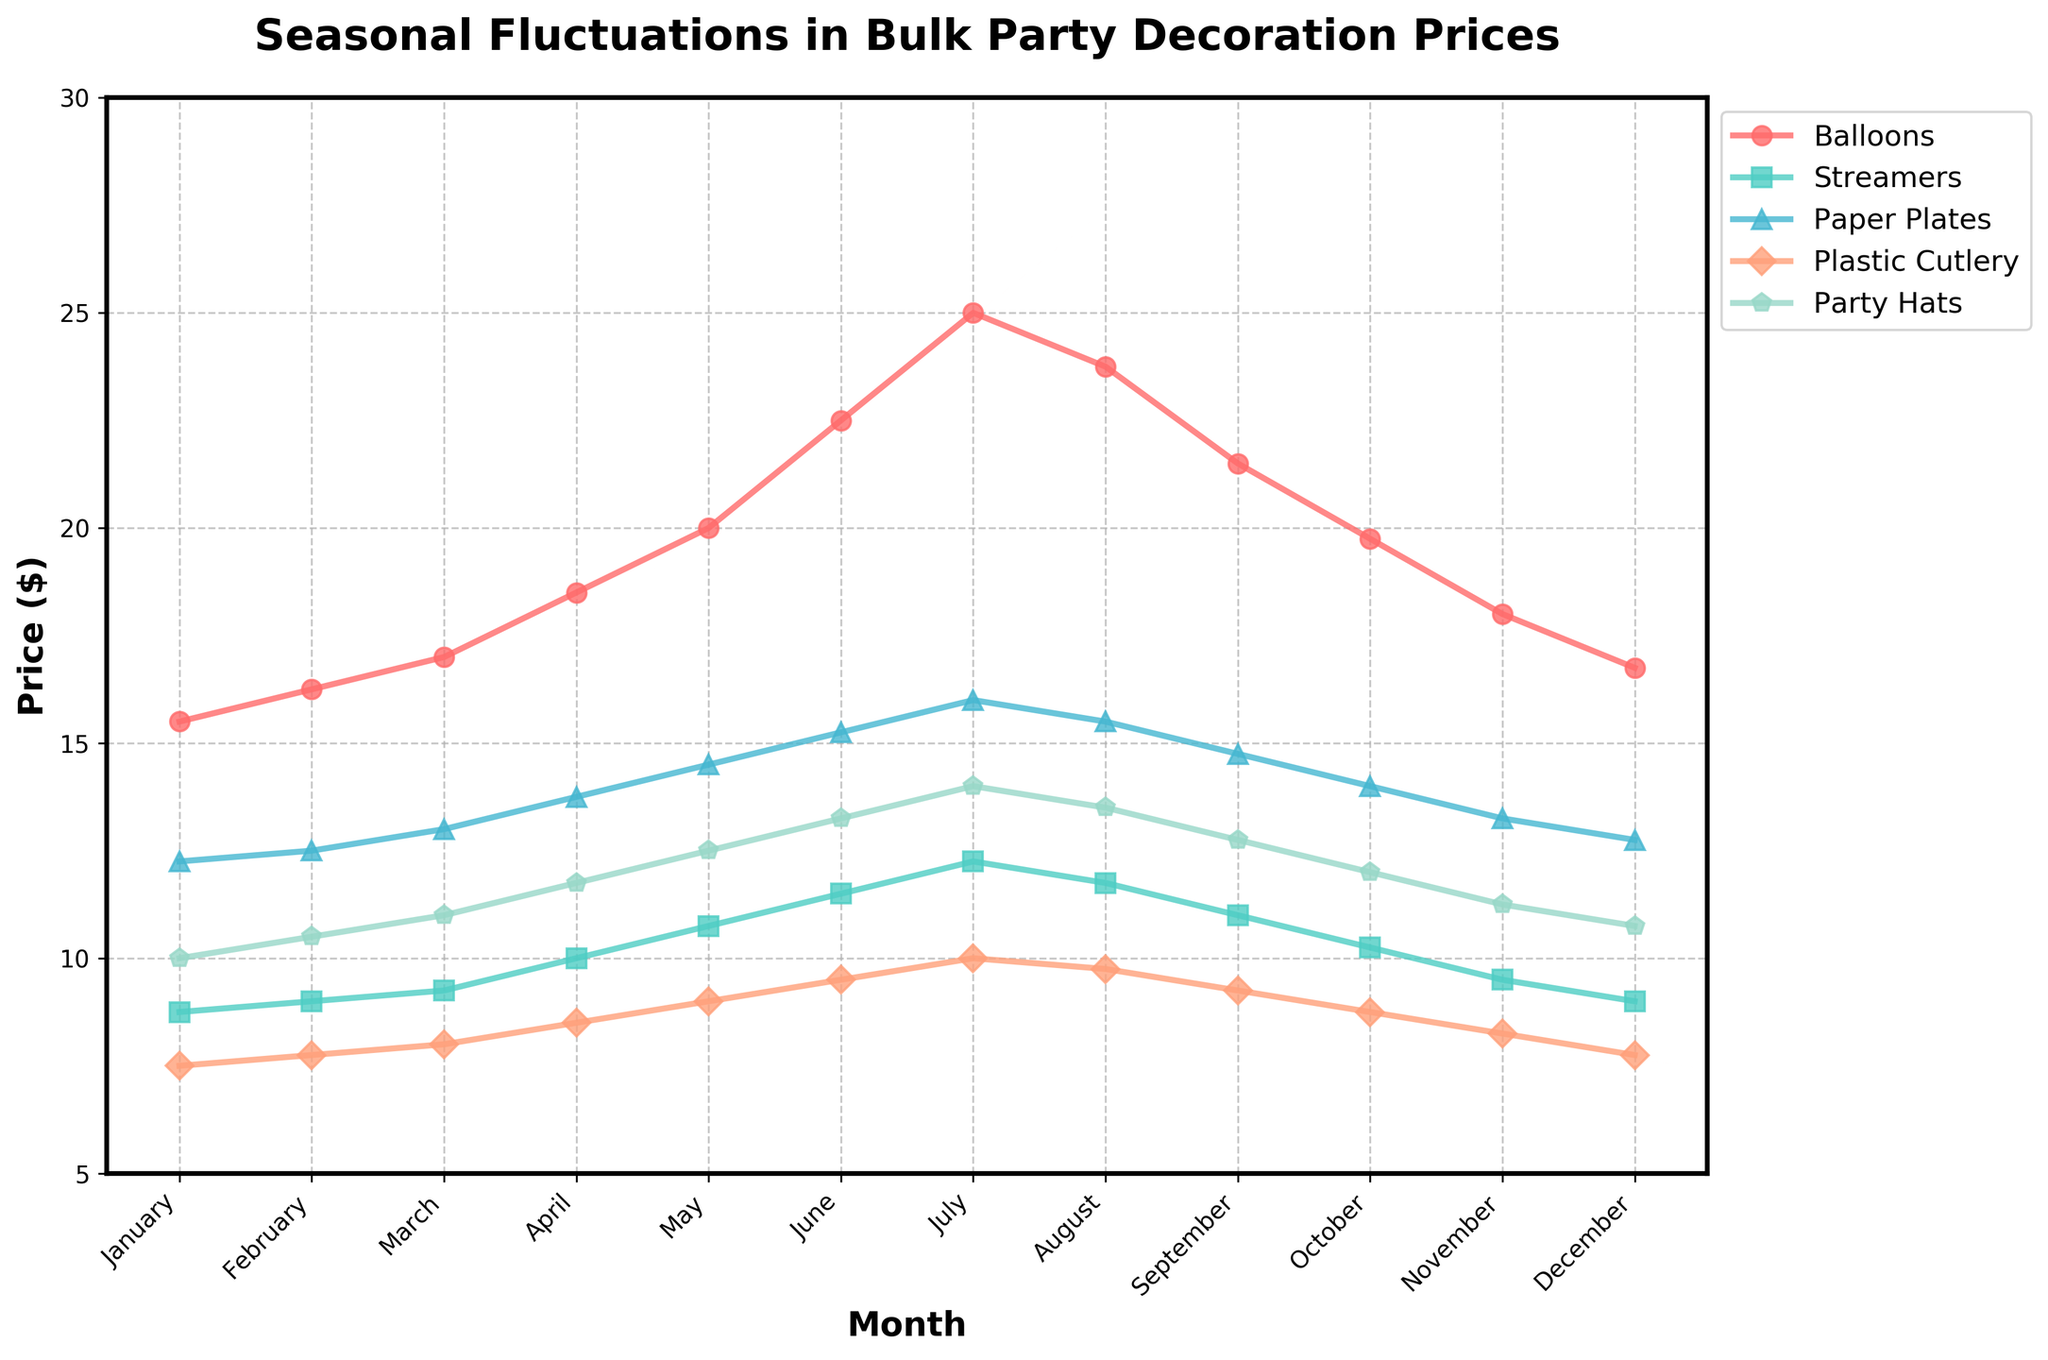What month has the highest price for Balloons? By looking at the price line for Balloons, we see the highest peak in July. This represents the highest price.
Answer: July In which month do Paper Plates reach their lowest price? The lowest point on the price line for Paper Plates is in January. This is where the price is lowest.
Answer: January Which item shows the most significant price increase from January to July? By examining the lines' behavior for each item from January to July, we see that the Balloons' line shows the steepest rise in price.
Answer: Balloons Compare the prices of Streamers and Party Hats in May. Which is higher? Locate May on the x-axis, track the prices for Streamers and Party Hats; Streamers are $10.75 while Party Hats are $12.50. Party Hats cost more.
Answer: Party Hats What is the average price of Plastic Cutlery in the first quarter (January to March)? Sum up the prices of Plastic Cutlery from January to March (7.50 + 7.75 + 8.00 = 23.25) and divide by 3 months.
Answer: 7.75 During which month is the price difference between Paper Plates and Balloons the widest? By calculating the monthly differences between Paper Plates and Balloons, the widest gap occurs in July (difference = 25.00 - 16.00 = 9.00).
Answer: July Which month shows the smallest variance among all items' prices? By examining the fluctuations in all five lines, December shows the smallest spread in prices (differences between items' prices are minimal).
Answer: December Is the price of Balloons higher than the price of Party Hats in October? Locate October, observe that Balloons' price is $19.75 while Party Hats’ price is $12.00; hence, Balloons are higher.
Answer: Yes In which month do Streamers and Plastic Cutlery have identical prices? By scanning the lines for intersection points, we identify an intersection in February where both prices are $9.00.
Answer: February 